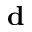<formula> <loc_0><loc_0><loc_500><loc_500>d</formula> 